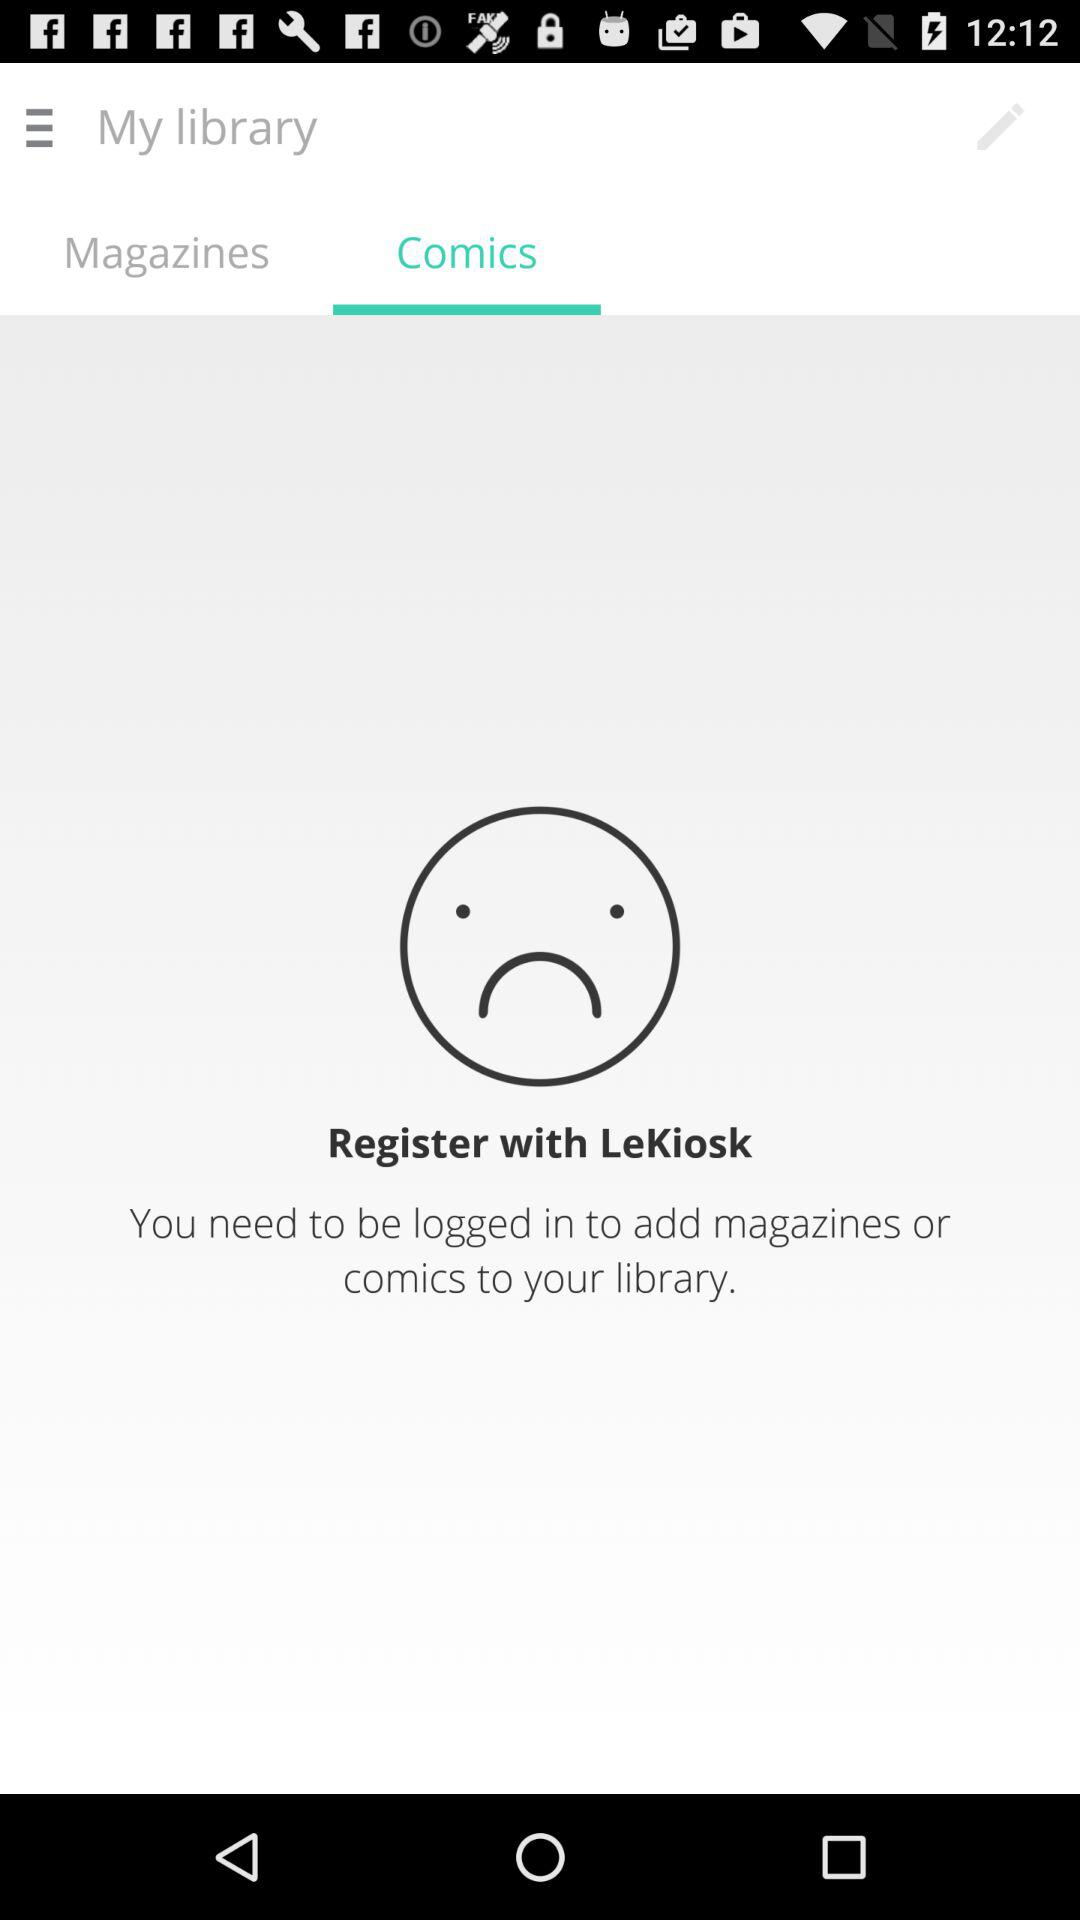What is the name of the application? The name of the application is "LeKiosk". 